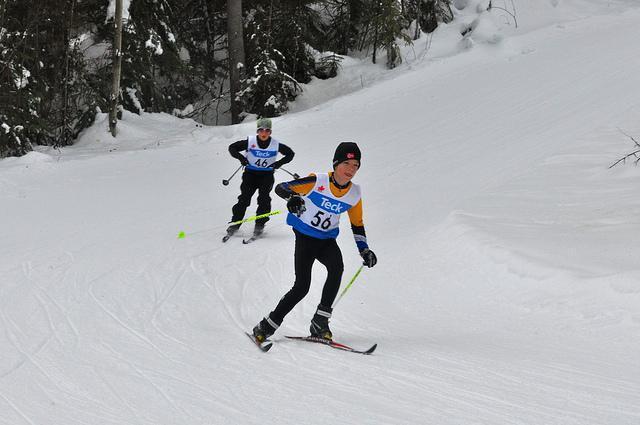How many people are in the picture?
Give a very brief answer. 2. 